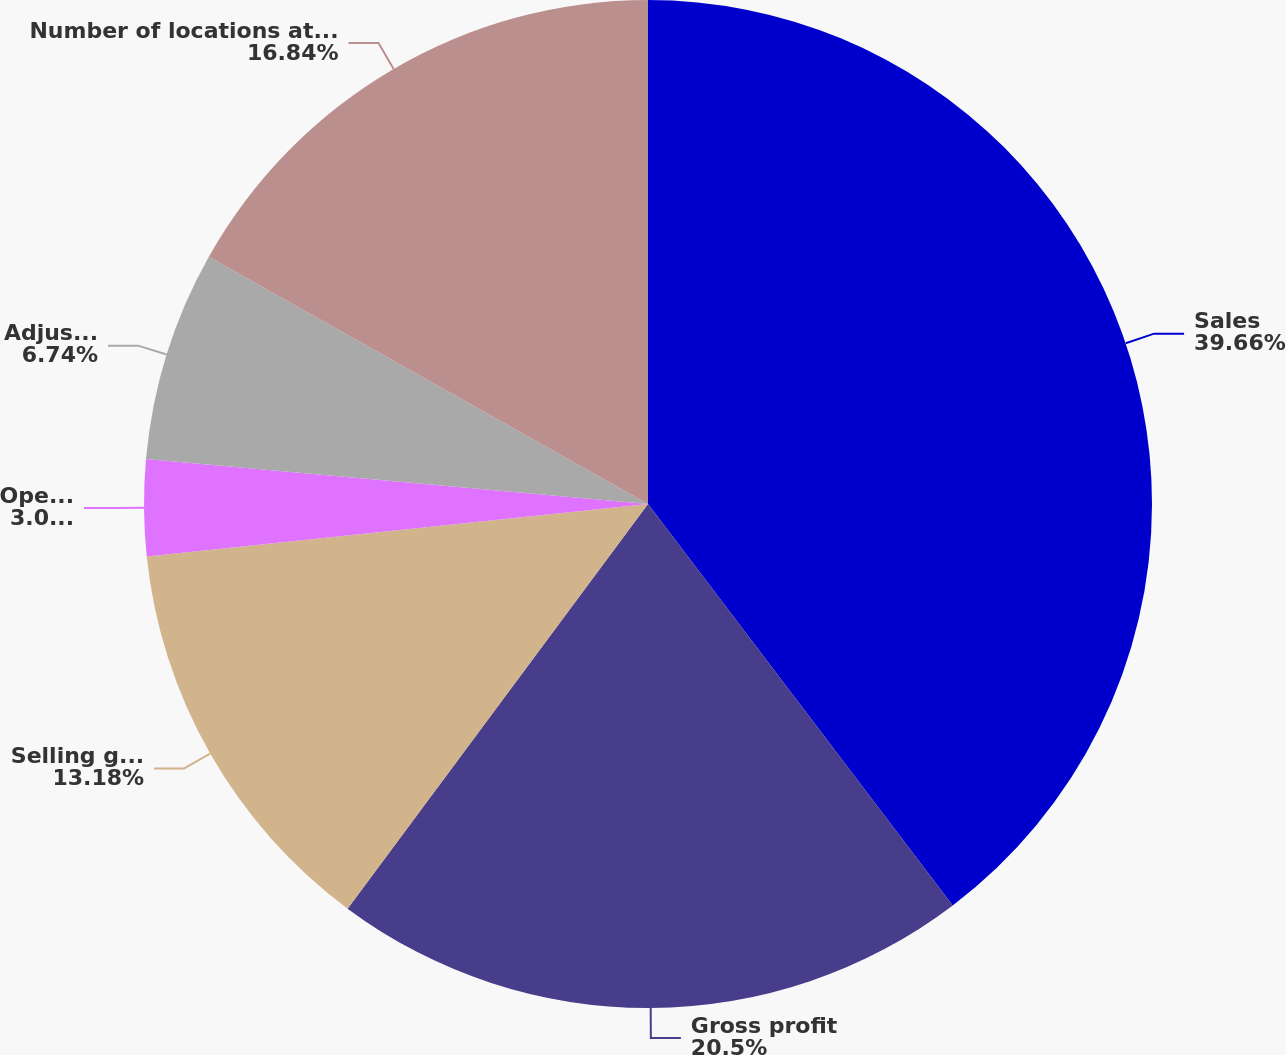<chart> <loc_0><loc_0><loc_500><loc_500><pie_chart><fcel>Sales<fcel>Gross profit<fcel>Selling general and<fcel>Operating income<fcel>Adjusted operating income<fcel>Number of locations at period<nl><fcel>39.67%<fcel>20.5%<fcel>13.18%<fcel>3.08%<fcel>6.74%<fcel>16.84%<nl></chart> 